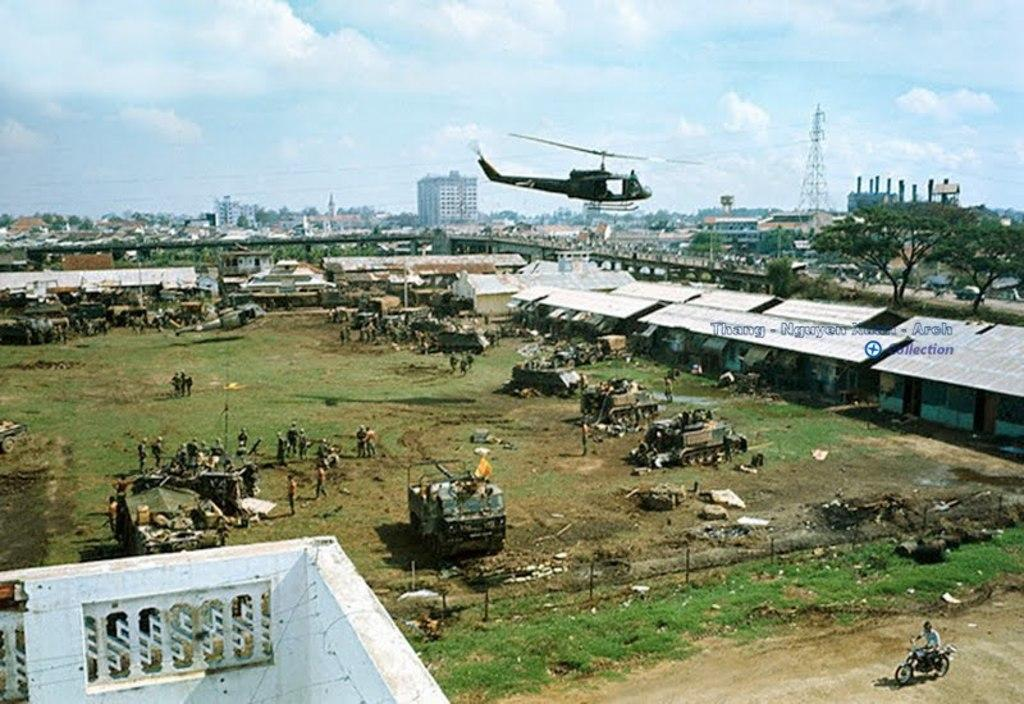What type of structures can be seen in the image? There are buildings in the image. Can you describe the people in the image? There is a group of people in the image. What type of machinery is present in the image? Bulldozers are present in the image. Are there any other vehicles visible in the image? Yes, other vehicles are visible in the image. What type of vegetation is present in the image? There is grass in the image. What can be seen in the background of the image? The sky is visible in the background of the image. How many children are playing with the stocking in the image? There is no stocking or children present in the image. What type of bird is part of the flock in the image? There is no flock of birds present in the image. 